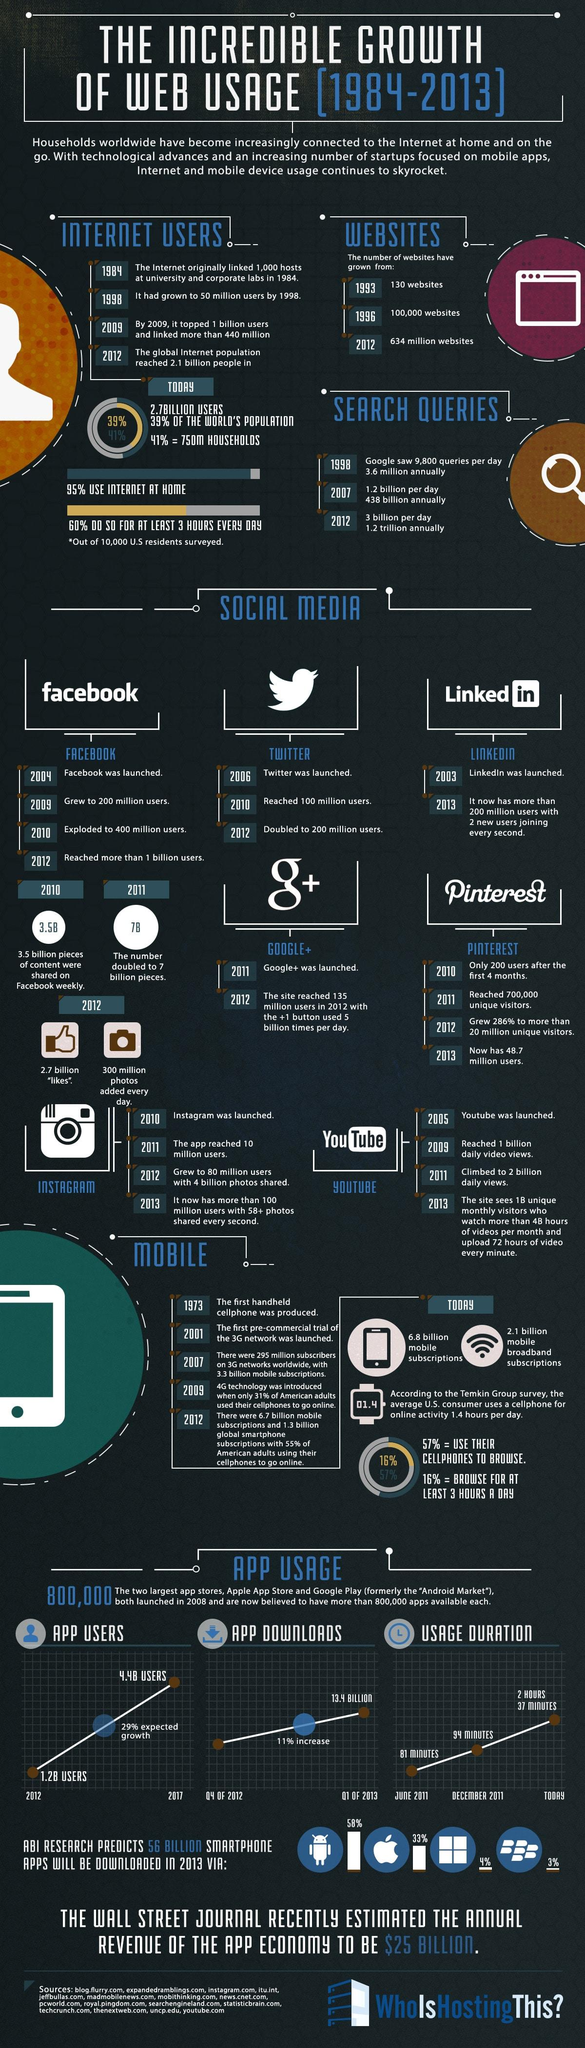Specify some key components in this picture. In 2010, Pinterest had only 200 users after its first 4 months of operation. Instagram reached 10 million users in 2011, making it the app that attained this milestone that year. In 2013, it is projected that 33% of smartphone apps will be downloaded via Apple phones. Facebook, LinkedIn, and Twitter were all launched at different times, but LinkedIn was launched earlier than the other two. Twitter reached 100 million users in 2010, making it the first social network to achieve this milestone. 